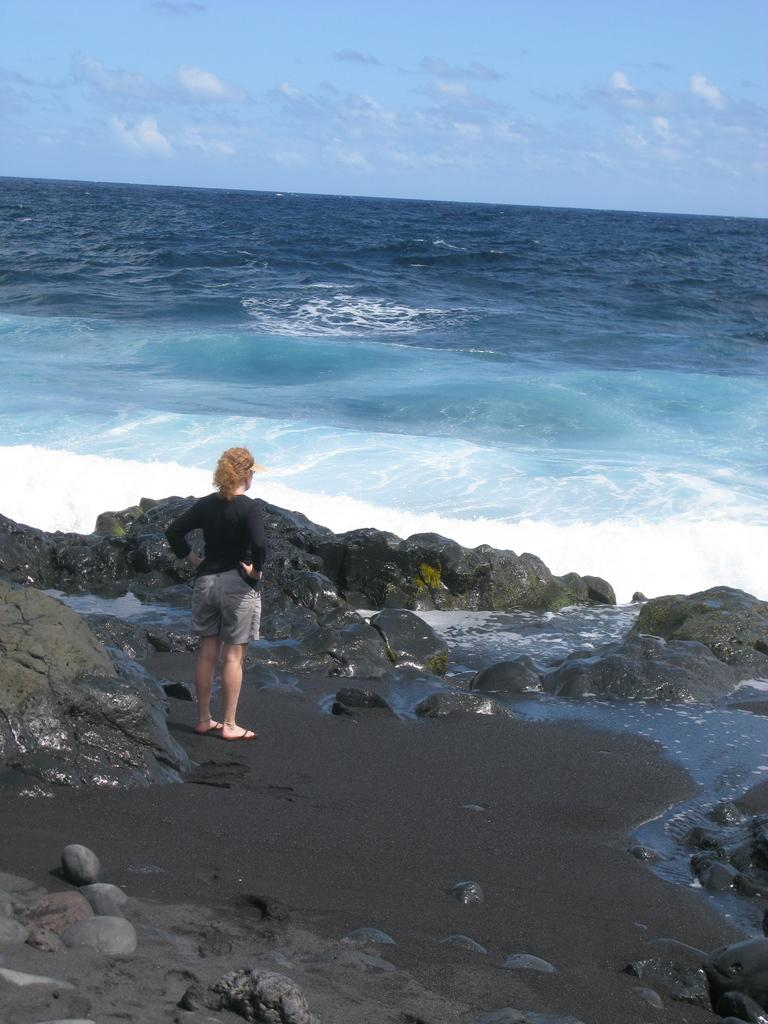Where was the image taken? The image was taken at a beach. What can be seen in the image besides the beach? There is a woman standing in the image, and rocks are visible. What is visible in the sky in the image? The sky is visible in the image, and clouds are present. What type of skirt is the mice wearing in the image? There are no mice or skirts present in the image. 